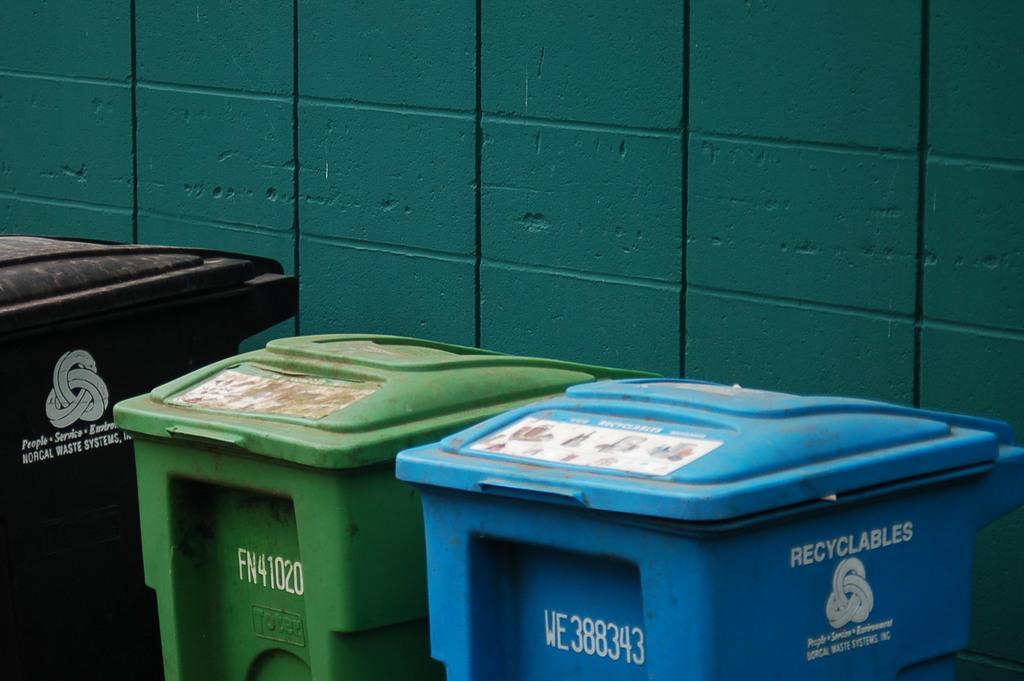In one or two sentences, can you explain what this image depicts? In the image I can see three bins on which there is something written and behind there is a green wall. 